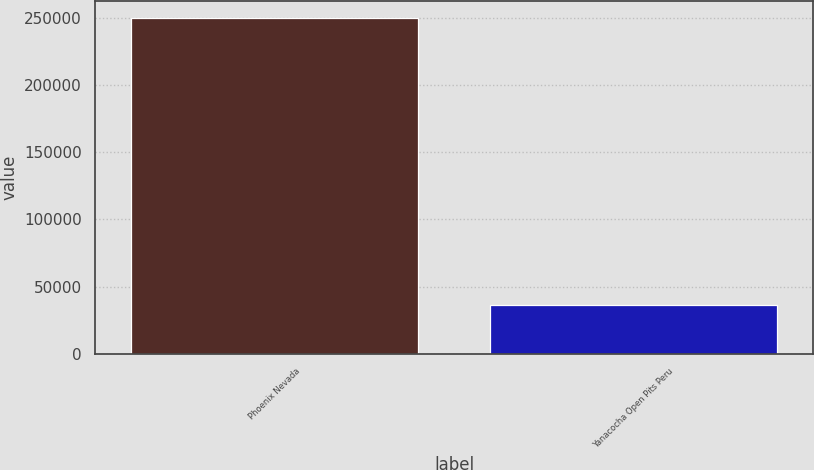Convert chart. <chart><loc_0><loc_0><loc_500><loc_500><bar_chart><fcel>Phoenix Nevada<fcel>Yanacocha Open Pits Peru<nl><fcel>249900<fcel>36600<nl></chart> 